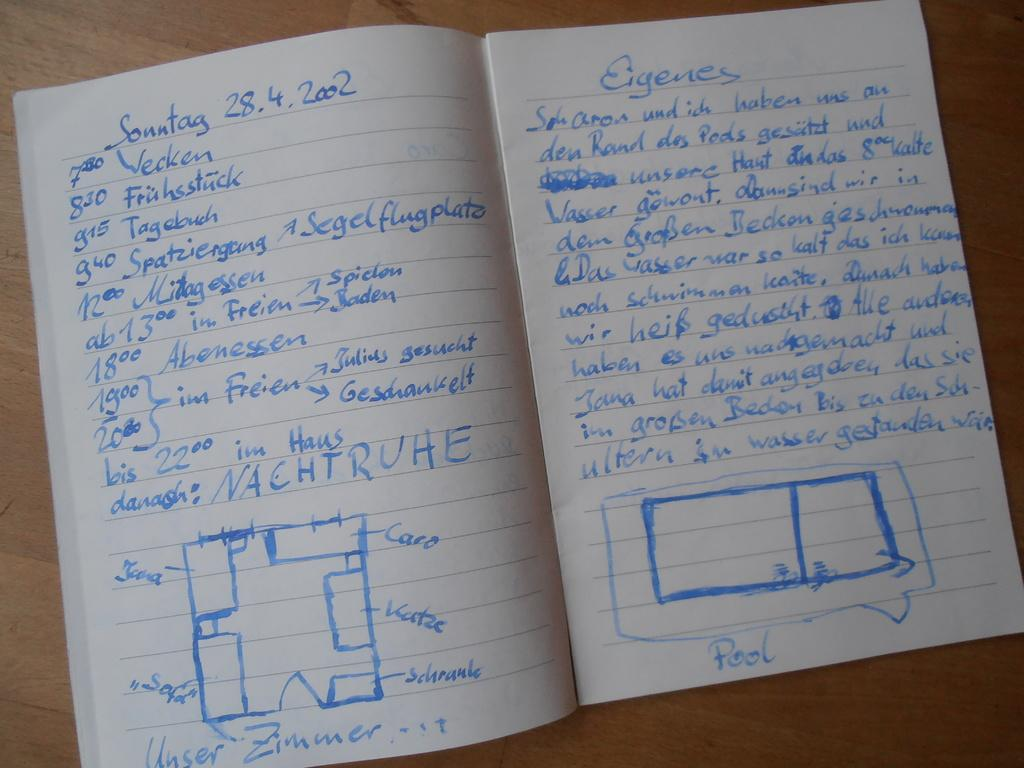<image>
Create a compact narrative representing the image presented. Blue ink fills the pages of a notebook dated 28.4.2002. 